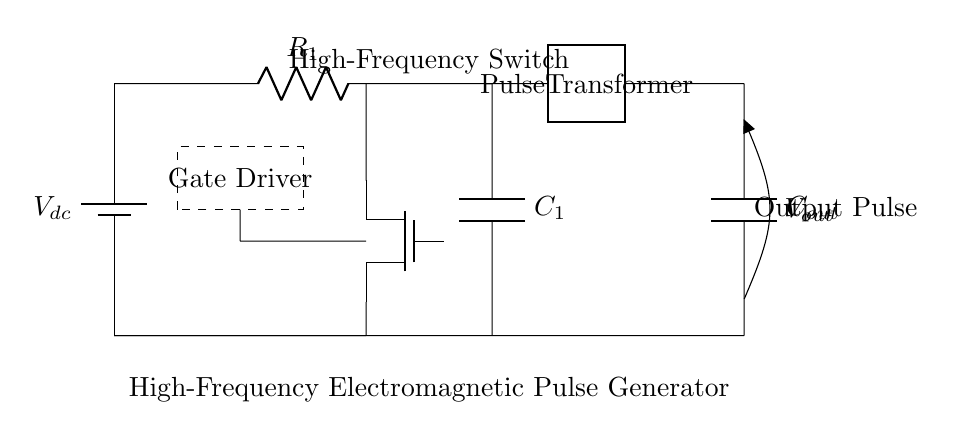What is the voltage source in the circuit? The voltage source is labeled as Vdc, which represents the DC voltage supplied to the circuit components.
Answer: Vdc What is the role of the MOSFET in this circuit? The MOSFET acts as a high-frequency switch to control the flow of current, enabling the generation of pulse signals.
Answer: High-frequency switch What does C1 represent in the circuit? C1 is a capacitor that, in conjunction with R1, helps in shaping the pulse output by controlling the charge and discharge rates.
Answer: Capacitor What is the output voltage labeled as? The output voltage is labeled as Vout, which indicates the voltage signal generated by the pulse transformer at the output.
Answer: Vout How is the gate driver connected in relation to the MOSFET? The gate driver is connected to the gate of the MOSFET to control its switching operation, which allows for pulse generation.
Answer: To the gate of the MOSFET What component is responsible for transforming the pulse? The component responsible for transforming the pulse is the pulse transformer, indicated in the diagram as a two-port device connecting the input and output stages.
Answer: Pulse transformer What is the purpose of the resistor labeled R1? The resistor R1 limits the current flowing in the circuit, thus affecting the frequency and shape of the output pulse.
Answer: Current limiting 